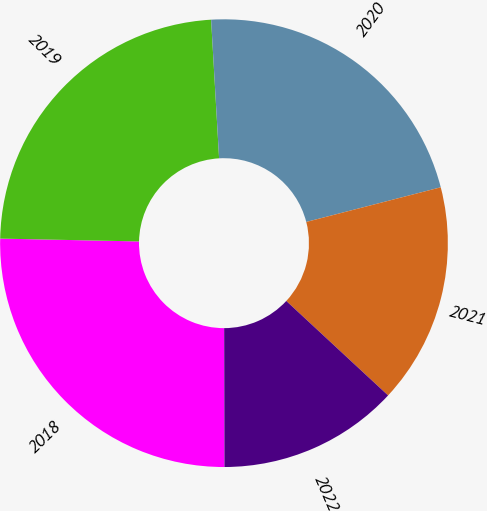<chart> <loc_0><loc_0><loc_500><loc_500><pie_chart><fcel>2018<fcel>2019<fcel>2020<fcel>2021<fcel>2022<nl><fcel>25.36%<fcel>23.76%<fcel>21.9%<fcel>15.92%<fcel>13.06%<nl></chart> 